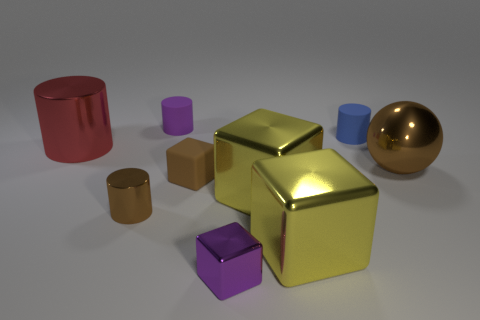Add 1 large red things. How many objects exist? 10 Subtract all cubes. How many objects are left? 5 Subtract all purple matte objects. Subtract all tiny brown blocks. How many objects are left? 7 Add 9 big shiny balls. How many big shiny balls are left? 10 Add 2 brown things. How many brown things exist? 5 Subtract 0 red cubes. How many objects are left? 9 